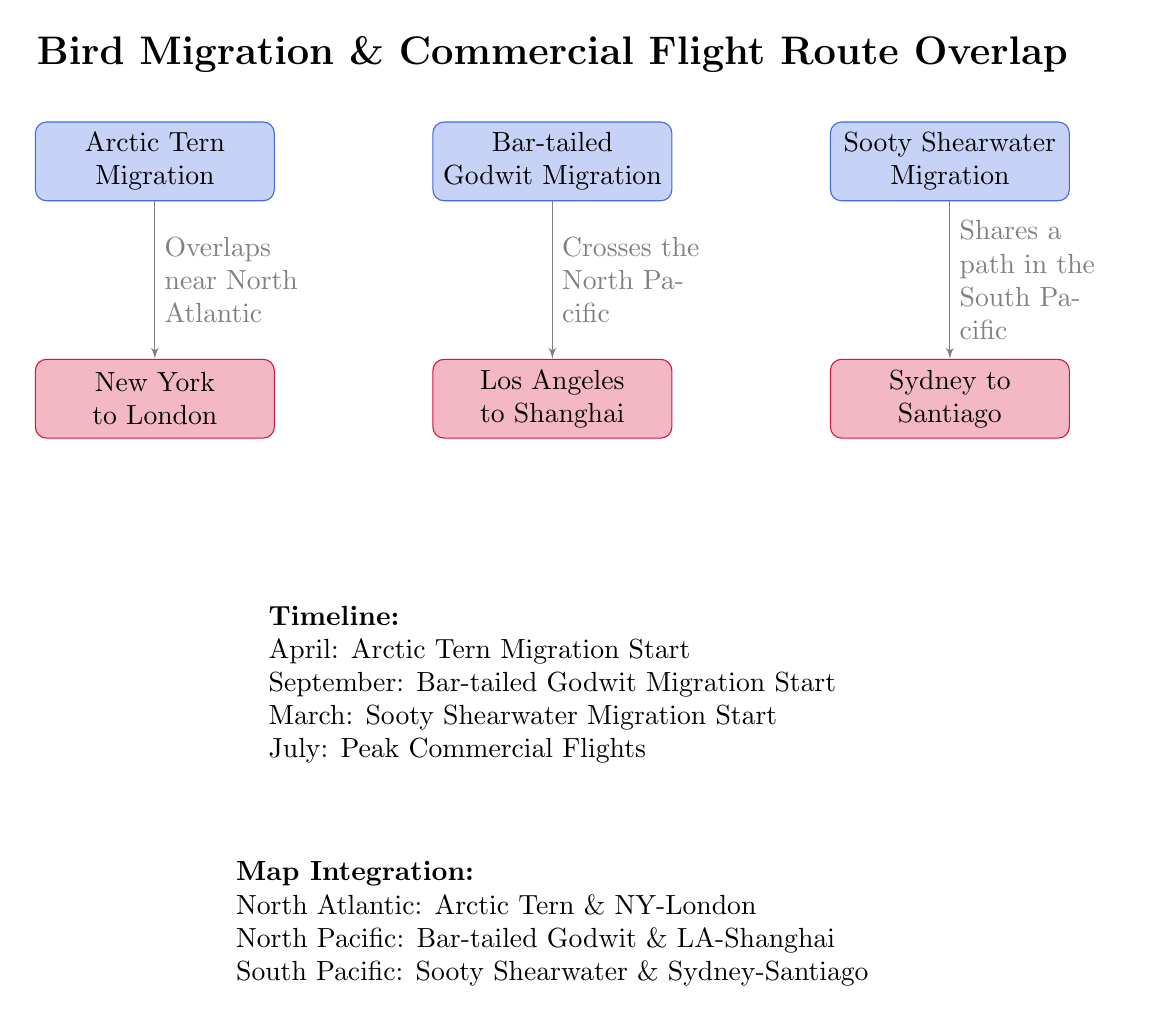What are the three bird migrations displayed in the diagram? The diagram lists three bird migrations: Arctic Tern, Bar-tailed Godwit, and Sooty Shearwater. Each is represented in a separate node labeled with the bird's name.
Answer: Arctic Tern, Bar-tailed Godwit, Sooty Shearwater Which commercial flight overlaps with Arctic Tern Migration? The diagram shows a line connecting the Arctic Tern Migration node to the New York to London flight node, indicating their overlap.
Answer: New York to London Where does the Bar-tailed Godwit Migration cross? The diagram indicates that the Bar-tailed Godwit Migration crosses the North Pacific, as noted in the description along the connecting line to the Los Angeles to Shanghai flight.
Answer: North Pacific What month does the Sooty Shearwater Migration start? According to the timeline in the diagram, the Sooty Shearwater Migration starts in March, which is directly stated in the timeline section.
Answer: March What is mentioned as the peak period for commercial flights? The timeline specifies that July is the peak period for commercial flights, which is indicated in the same section detailing the timeline of bird migrations.
Answer: July How many flight routes are depicted in the diagram? There are three flight routes depicted, as indicated by the three nodes labeled with commercial flight paths beneath the bird migration nodes, one for each bird type.
Answer: Three 